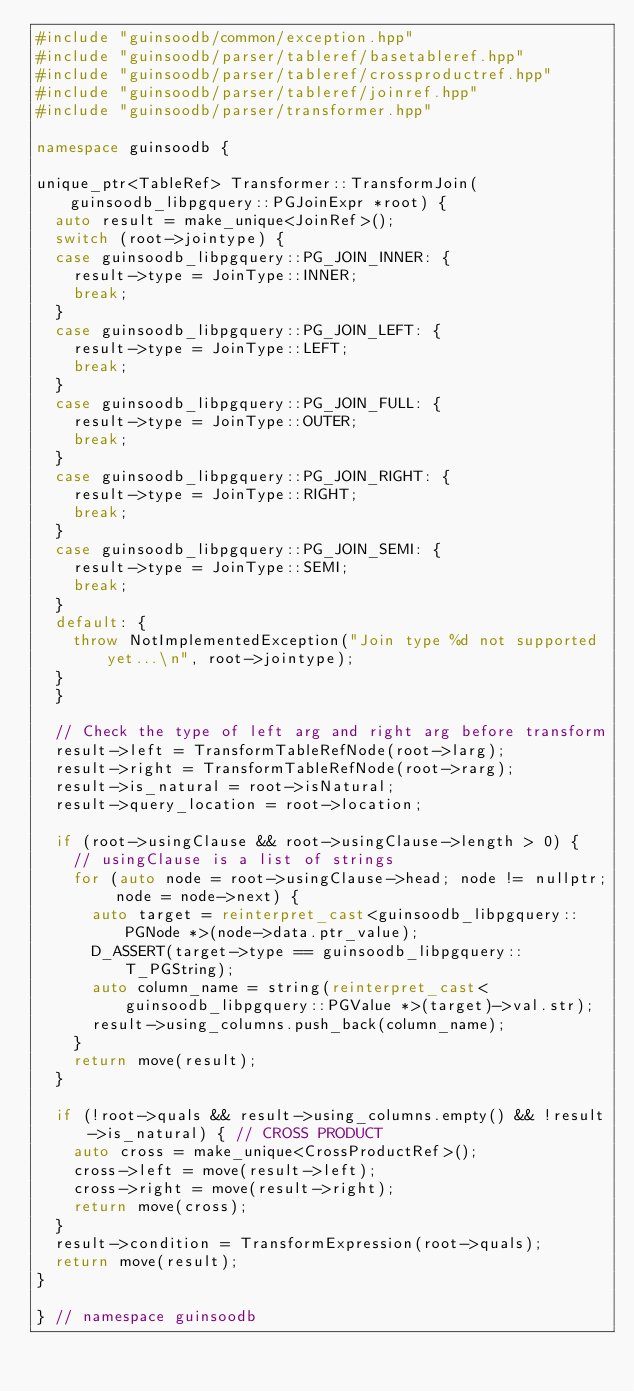Convert code to text. <code><loc_0><loc_0><loc_500><loc_500><_C++_>#include "guinsoodb/common/exception.hpp"
#include "guinsoodb/parser/tableref/basetableref.hpp"
#include "guinsoodb/parser/tableref/crossproductref.hpp"
#include "guinsoodb/parser/tableref/joinref.hpp"
#include "guinsoodb/parser/transformer.hpp"

namespace guinsoodb {

unique_ptr<TableRef> Transformer::TransformJoin(guinsoodb_libpgquery::PGJoinExpr *root) {
	auto result = make_unique<JoinRef>();
	switch (root->jointype) {
	case guinsoodb_libpgquery::PG_JOIN_INNER: {
		result->type = JoinType::INNER;
		break;
	}
	case guinsoodb_libpgquery::PG_JOIN_LEFT: {
		result->type = JoinType::LEFT;
		break;
	}
	case guinsoodb_libpgquery::PG_JOIN_FULL: {
		result->type = JoinType::OUTER;
		break;
	}
	case guinsoodb_libpgquery::PG_JOIN_RIGHT: {
		result->type = JoinType::RIGHT;
		break;
	}
	case guinsoodb_libpgquery::PG_JOIN_SEMI: {
		result->type = JoinType::SEMI;
		break;
	}
	default: {
		throw NotImplementedException("Join type %d not supported yet...\n", root->jointype);
	}
	}

	// Check the type of left arg and right arg before transform
	result->left = TransformTableRefNode(root->larg);
	result->right = TransformTableRefNode(root->rarg);
	result->is_natural = root->isNatural;
	result->query_location = root->location;

	if (root->usingClause && root->usingClause->length > 0) {
		// usingClause is a list of strings
		for (auto node = root->usingClause->head; node != nullptr; node = node->next) {
			auto target = reinterpret_cast<guinsoodb_libpgquery::PGNode *>(node->data.ptr_value);
			D_ASSERT(target->type == guinsoodb_libpgquery::T_PGString);
			auto column_name = string(reinterpret_cast<guinsoodb_libpgquery::PGValue *>(target)->val.str);
			result->using_columns.push_back(column_name);
		}
		return move(result);
	}

	if (!root->quals && result->using_columns.empty() && !result->is_natural) { // CROSS PRODUCT
		auto cross = make_unique<CrossProductRef>();
		cross->left = move(result->left);
		cross->right = move(result->right);
		return move(cross);
	}
	result->condition = TransformExpression(root->quals);
	return move(result);
}

} // namespace guinsoodb
</code> 